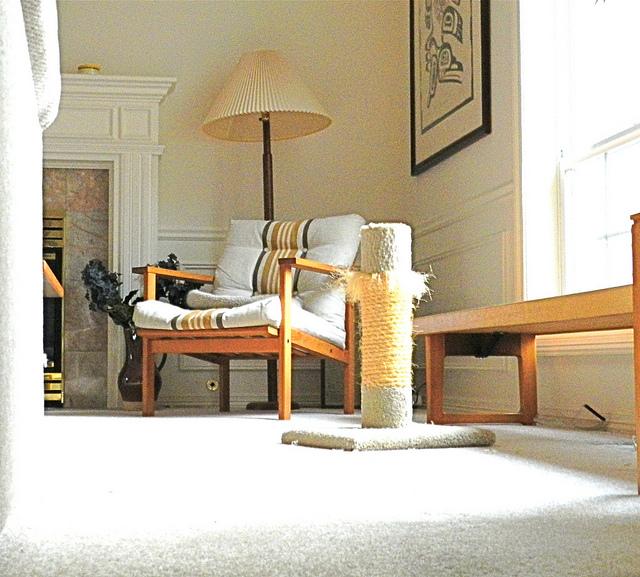Is there an item on top of the fireplace?
Be succinct. Yes. What color is the lamp?
Give a very brief answer. Beige. Is it night time?
Keep it brief. No. Who made the art on the wall?
Concise answer only. Picasso. Is the photo blurry?
Be succinct. No. Is it day time?
Quick response, please. Yes. 